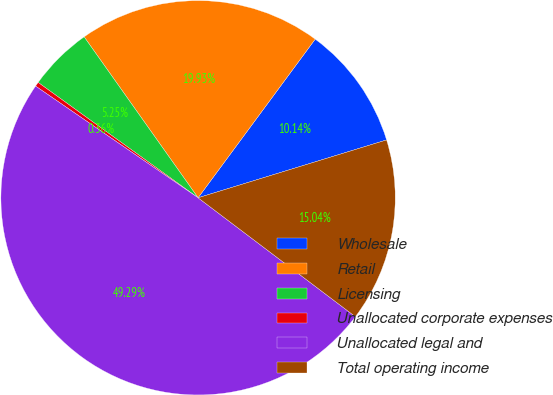Convert chart. <chart><loc_0><loc_0><loc_500><loc_500><pie_chart><fcel>Wholesale<fcel>Retail<fcel>Licensing<fcel>Unallocated corporate expenses<fcel>Unallocated legal and<fcel>Total operating income<nl><fcel>10.14%<fcel>19.93%<fcel>5.25%<fcel>0.36%<fcel>49.29%<fcel>15.04%<nl></chart> 